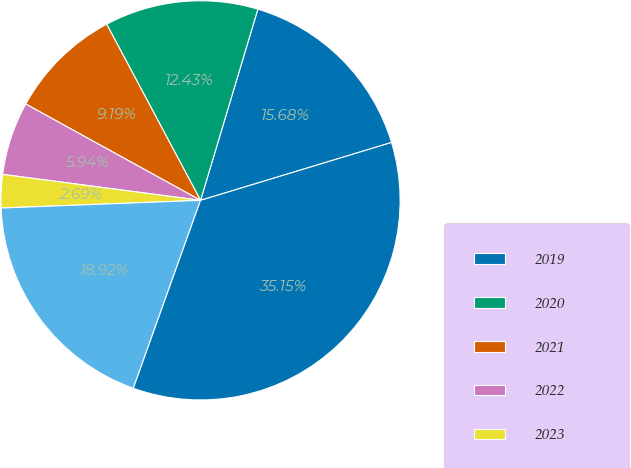Convert chart. <chart><loc_0><loc_0><loc_500><loc_500><pie_chart><fcel>2019<fcel>2020<fcel>2021<fcel>2022<fcel>2023<fcel>Thereafter<fcel>Total<nl><fcel>15.68%<fcel>12.43%<fcel>9.19%<fcel>5.94%<fcel>2.69%<fcel>18.92%<fcel>35.15%<nl></chart> 